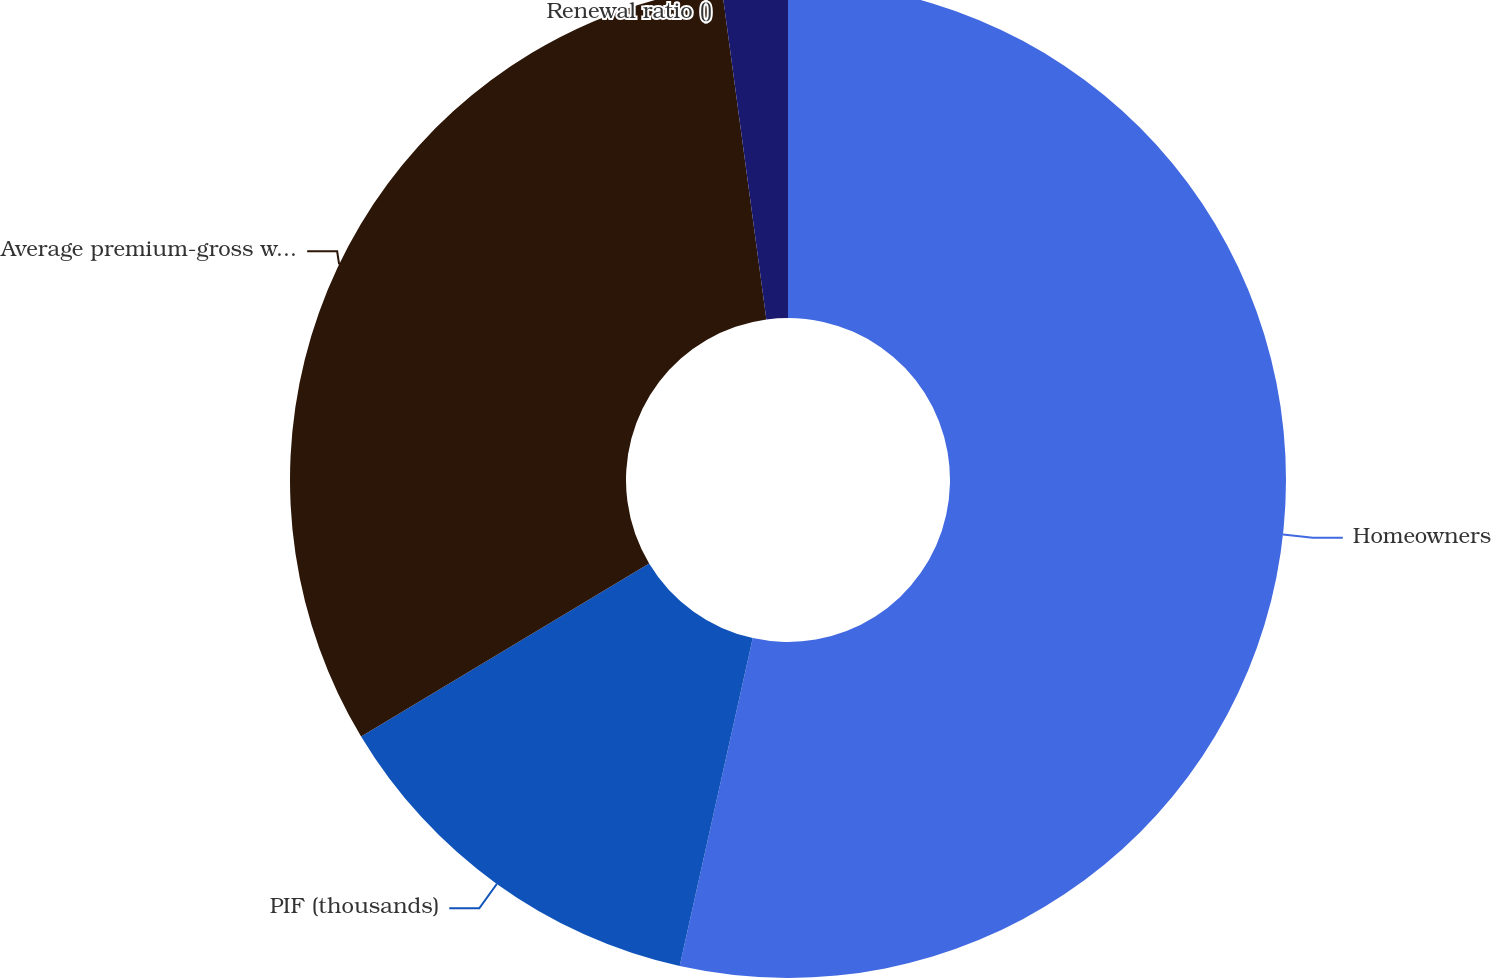Convert chart to OTSL. <chart><loc_0><loc_0><loc_500><loc_500><pie_chart><fcel>Homeowners<fcel>PIF (thousands)<fcel>Average premium-gross written<fcel>Renewal ratio ()<nl><fcel>53.49%<fcel>12.9%<fcel>31.48%<fcel>2.13%<nl></chart> 